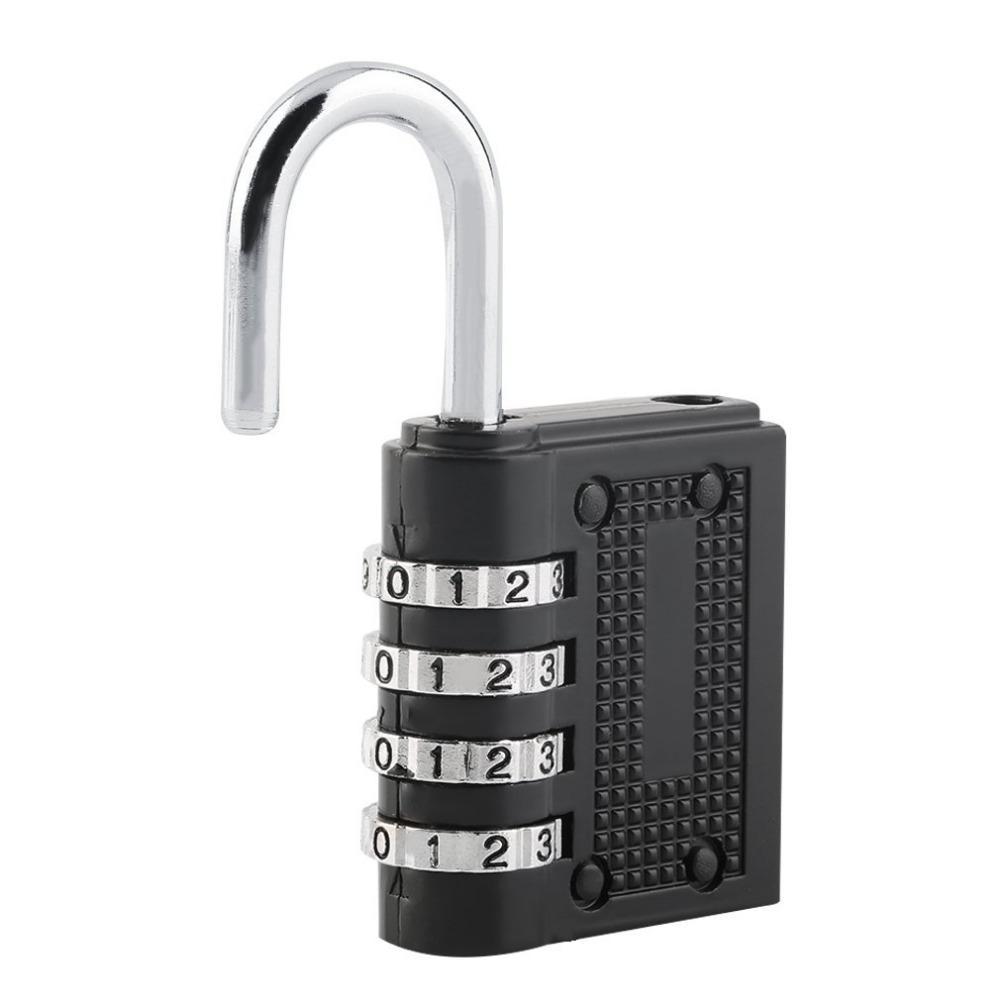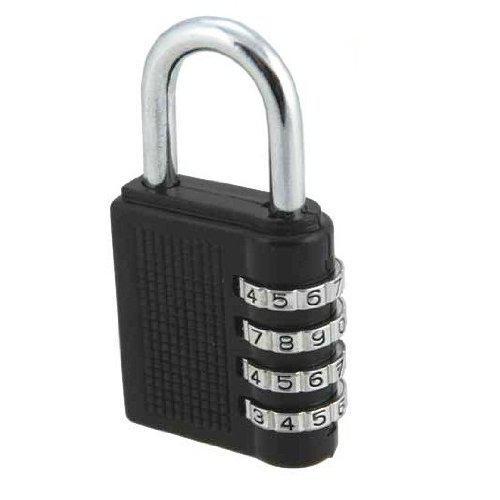The first image is the image on the left, the second image is the image on the right. For the images displayed, is the sentence "In one image in each pair a lock is unlocked and open." factually correct? Answer yes or no. Yes. The first image is the image on the left, the second image is the image on the right. For the images shown, is this caption "We have two combination locks." true? Answer yes or no. Yes. 